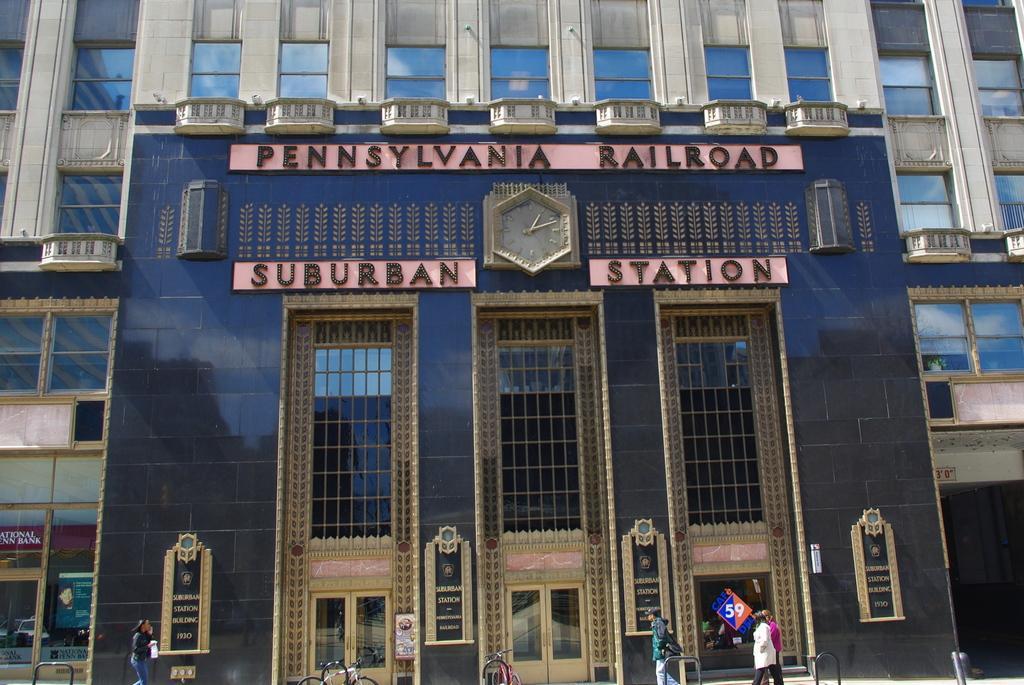Please provide a concise description of this image. In this picture I can see building and text on the walls of the building and I can see few people walking and couple of bicycles parked. 